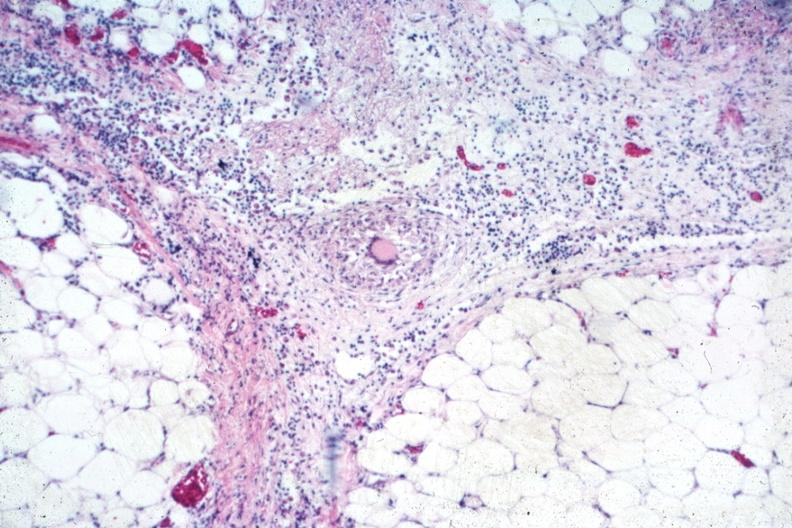s tuberculosis present?
Answer the question using a single word or phrase. Yes 